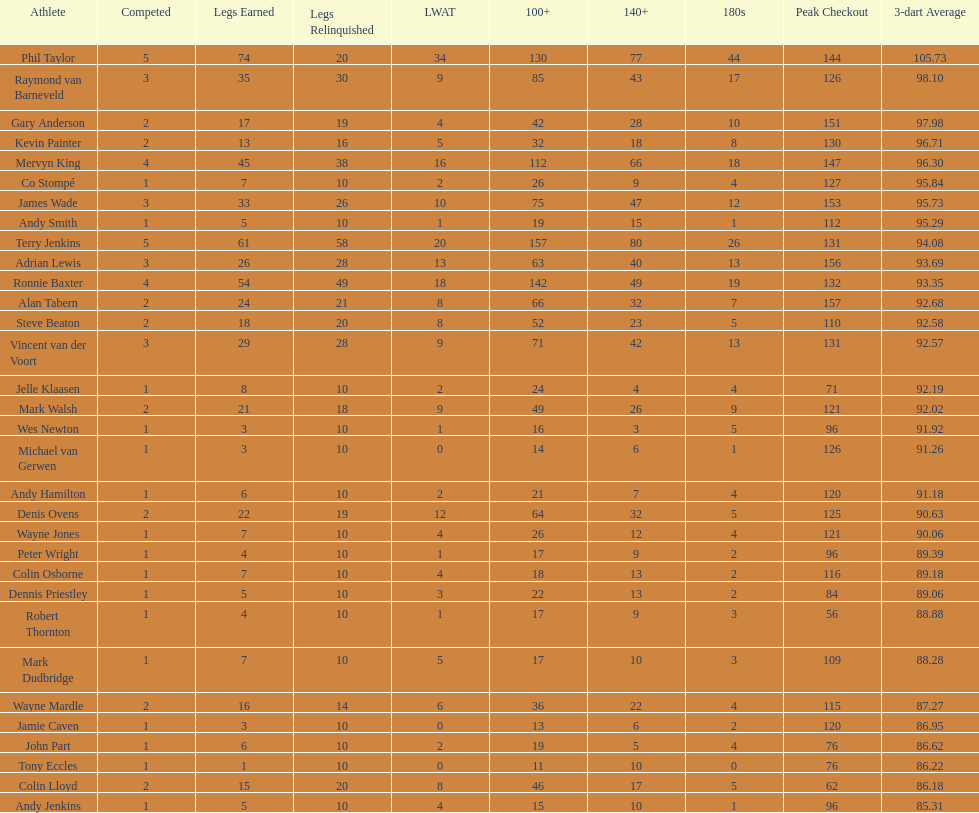How many players possess a 3-dart average exceeding 97? 3. 